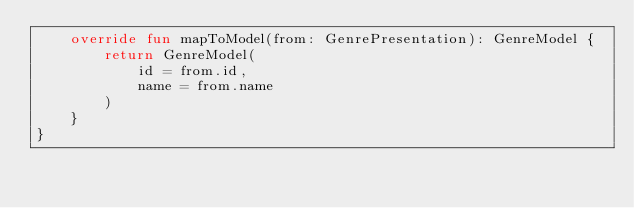Convert code to text. <code><loc_0><loc_0><loc_500><loc_500><_Kotlin_>    override fun mapToModel(from: GenrePresentation): GenreModel {
        return GenreModel(
            id = from.id,
            name = from.name
        )
    }
}</code> 